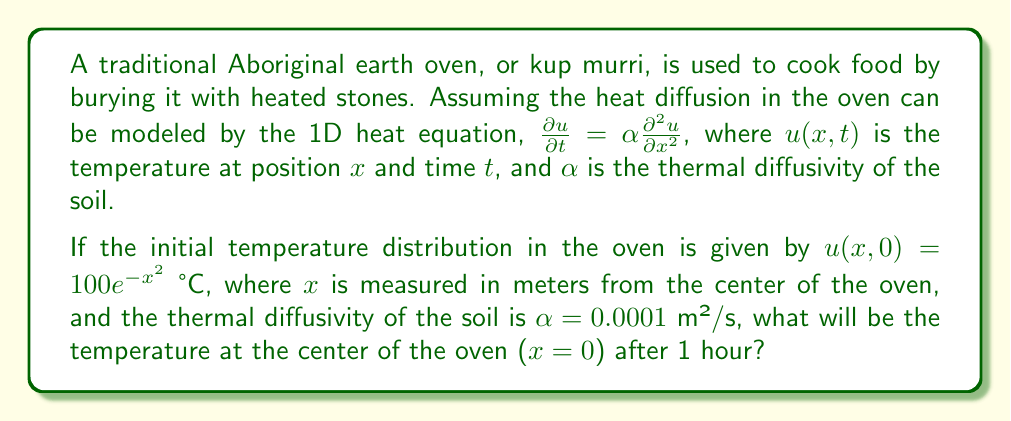Provide a solution to this math problem. To solve this problem, we need to use the solution to the 1D heat equation with an initial Gaussian distribution. The solution is given by:

$$u(x,t) = \frac{100}{\sqrt{1+4\alpha t}} e^{-\frac{x^2}{1+4\alpha t}}$$

Let's follow these steps:

1) We know that $\alpha = 0.0001$ m²/s and we want to find the temperature after 1 hour, so $t = 3600$ s.

2) We're interested in the temperature at the center, so $x = 0$.

3) Let's substitute these values into our equation:

   $$u(0,3600) = \frac{100}{\sqrt{1+4(0.0001)(3600)}} e^{-\frac{0^2}{1+4(0.0001)(3600)}}$$

4) Simplify the denominator under the square root:
   
   $$u(0,3600) = \frac{100}{\sqrt{1+1.44}} e^0$$

5) Calculate:
   
   $$u(0,3600) = \frac{100}{\sqrt{2.44}} = \frac{100}{1.56} = 64.1$$

Therefore, the temperature at the center of the oven after 1 hour will be approximately 64.1°C.
Answer: 64.1°C 